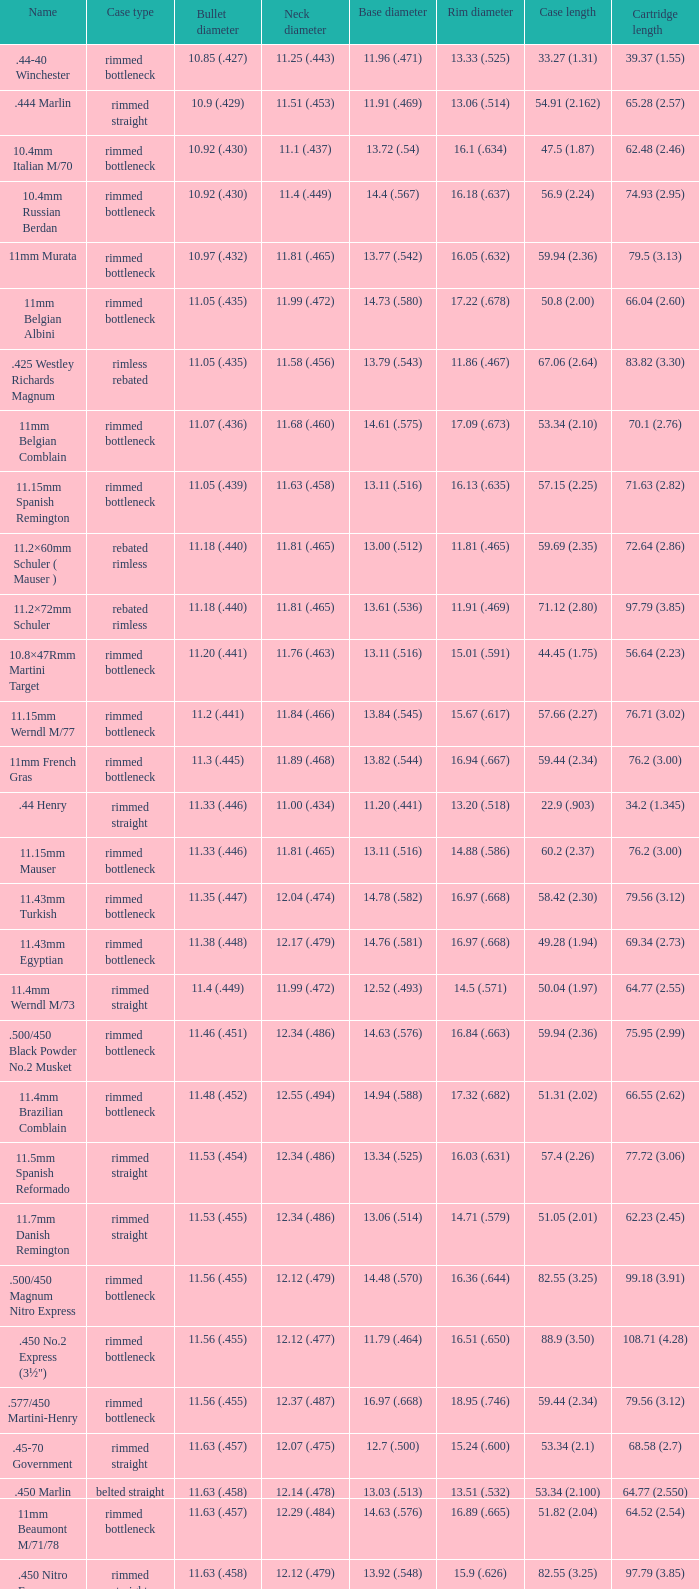Which rim diameter corresponds to a neck diameter of 1 15.67 (.617). 